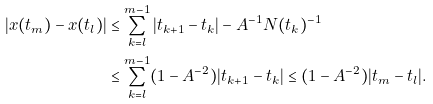Convert formula to latex. <formula><loc_0><loc_0><loc_500><loc_500>| x ( t _ { m } ) - x ( t _ { l } ) | & \leq \sum _ { k = l } ^ { m - 1 } | t _ { k + 1 } - t _ { k } | - A ^ { - 1 } N ( t _ { k } ) ^ { - 1 } \\ & \leq \sum _ { k = l } ^ { m - 1 } ( 1 - A ^ { - 2 } ) | t _ { k + 1 } - t _ { k } | \leq ( 1 - A ^ { - 2 } ) | t _ { m } - t _ { l } | .</formula> 